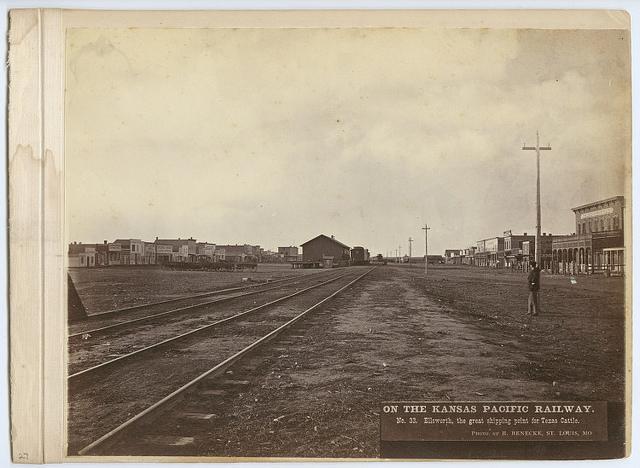What are the weather conditions in this picture?
Give a very brief answer. Cloudy. Is this an old photo?
Concise answer only. Yes. What is this a photo of?
Be succinct. Kansas pacific railway. 